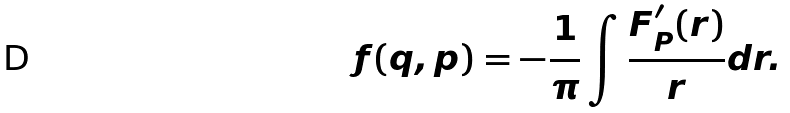Convert formula to latex. <formula><loc_0><loc_0><loc_500><loc_500>f ( q , p ) = - \frac { 1 } { \pi } \int \frac { F ^ { \prime } _ { P } ( r ) } { r } d r .</formula> 